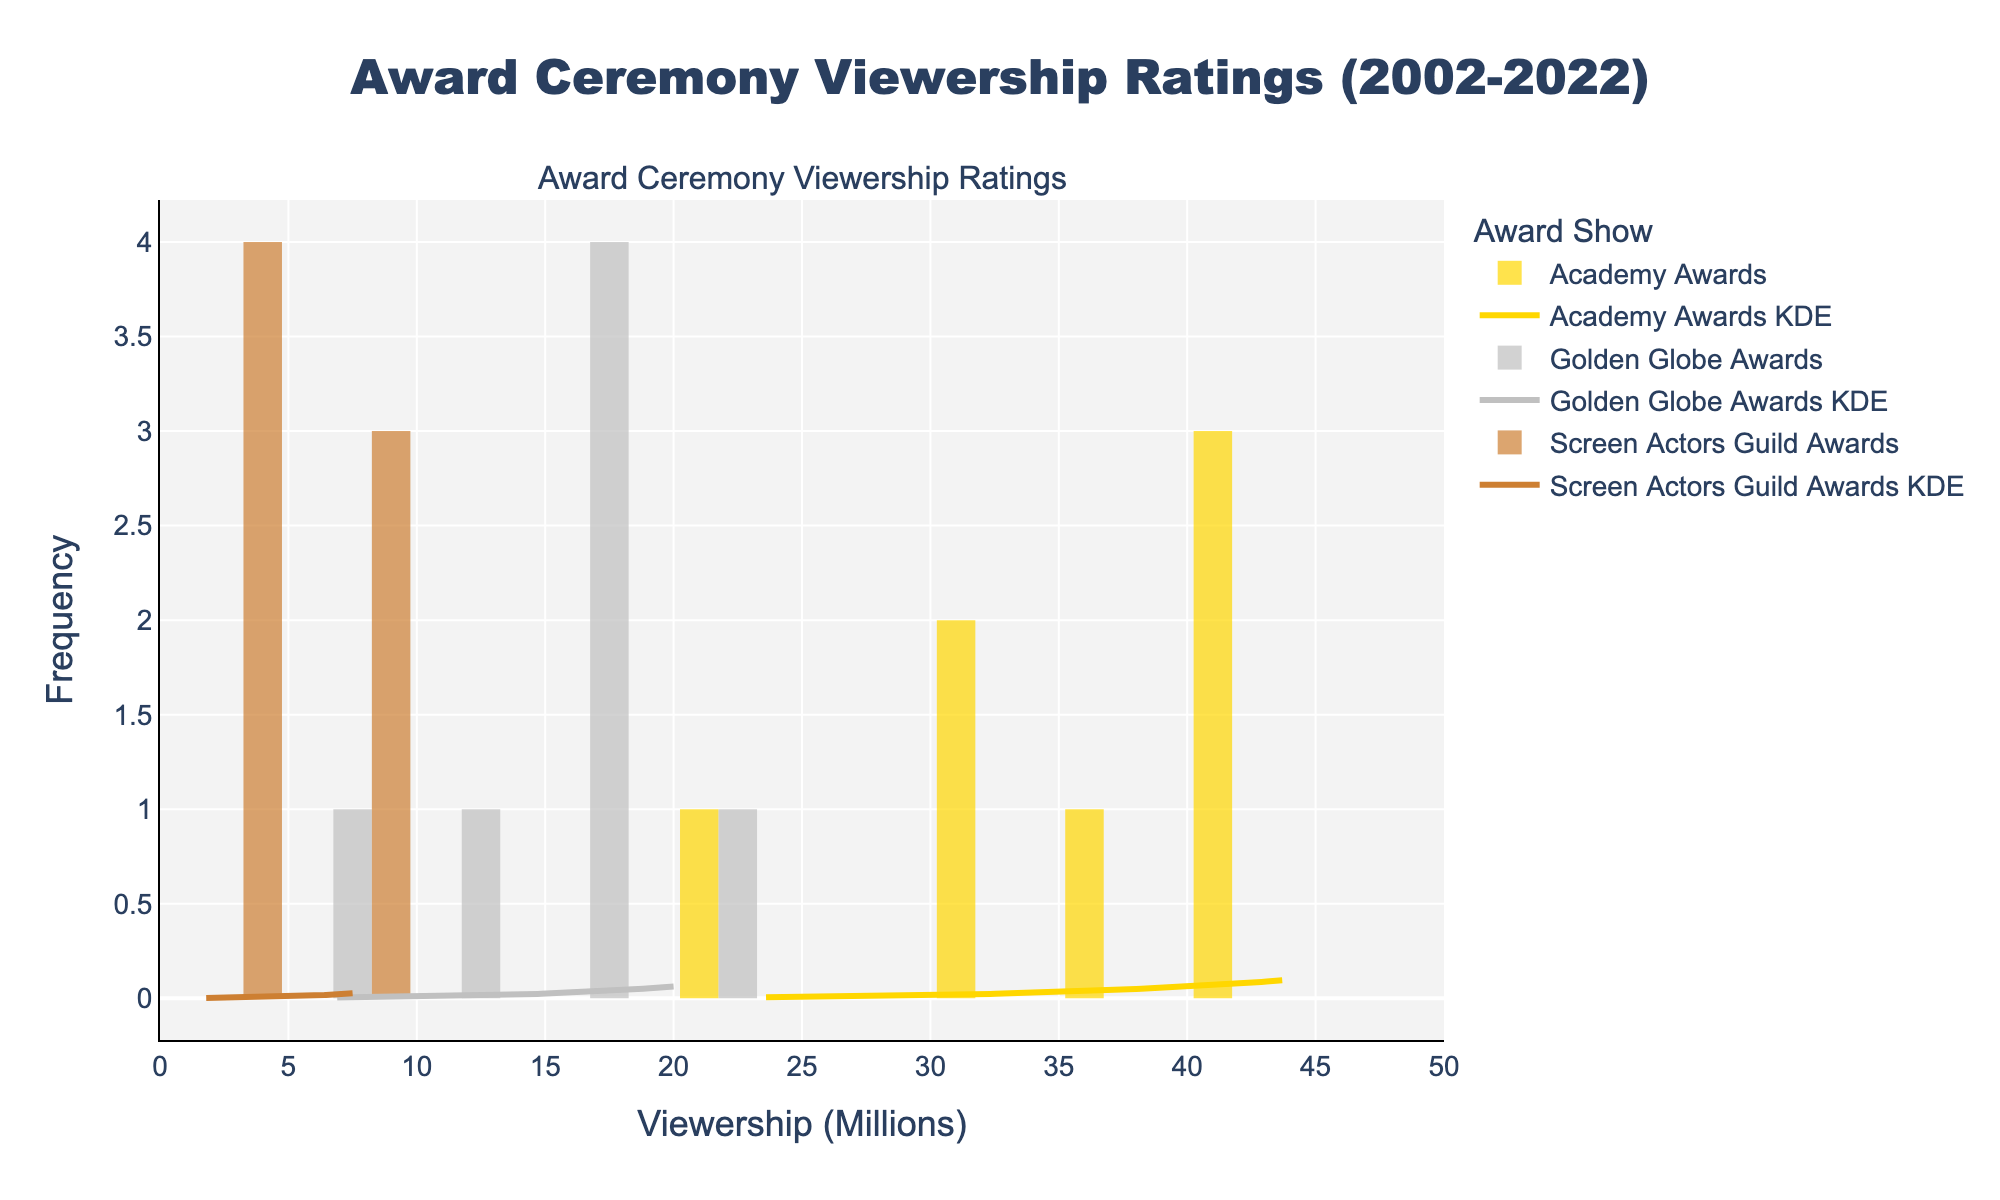what is the title of the figure? Look at the top area of the plot where the main heading is typically placed.
Answer: Award Ceremony Viewership Ratings (2002-2022) which award show has the highest peak in viewership density? Examine the KDE curves and histogram peaks to determine the award show with the highest density.
Answer: Academy Awards what is the range of viewership covered on the x-axis? Check the x-axis labels to see the minimum and maximum values displayed.
Answer: 0 to 50 million which award show has the lowest viewership density peak? Look for the KDE curve with the smallest peak value.
Answer: Screen Actors Guild Awards how many data points are there for the Academy Awards in the histogram? Count the bars in the Academy Awards' histogram and refer to the heights of these bars to tally the data points.
Answer: 7 what can you infer about the trend in viewership for the Golden Globe Awards compared to the Academy Awards? Compare the spread and peaks of the KDE curves for both awards to infer their trends. The Golden Globe Awards' density is lower and more evenly spread, indicating a less consistent viewership compared to the Academy Awards.
Answer: Lower and less consistent viewership for Golden Globe Awards compared to Academy Awards are there any overlap(s) in viewership density between the award shows? Observe any regions where the KDE curves intersect with each other.
Answer: Yes which award show has the most variable viewership, and why? Assess the spread and shape of the histogram bars and KDE curves to determine variability. The Golden Globe Awards' density is lower and wider, indicating more variable viewership.
Answer: Golden Globe Awards, because of its wide and low KDE curve what's the approximate viewership peak for the Screen Actors Guild Awards' KDE curve? Observe the peak height of the Screen Actors Guild Awards' KDE curve on the y-axis, considering relative heights.
Answer: Approximately 2 compare the viewership of Academy Awards in 2002 and 2020. Locate both years on the histogram and compare their heights; 2002 has significantly higher bars indicating higher viewership.
Answer: 41.8 million in 2002, 23.6 million in 2020 